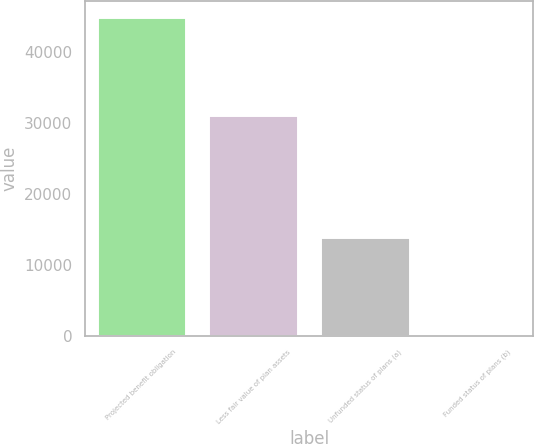<chart> <loc_0><loc_0><loc_500><loc_500><bar_chart><fcel>Projected benefit obligation<fcel>Less fair value of plan assets<fcel>Unfunded status of plans (a)<fcel>Funded status of plans (b)<nl><fcel>44946<fcel>31091<fcel>13855<fcel>208<nl></chart> 